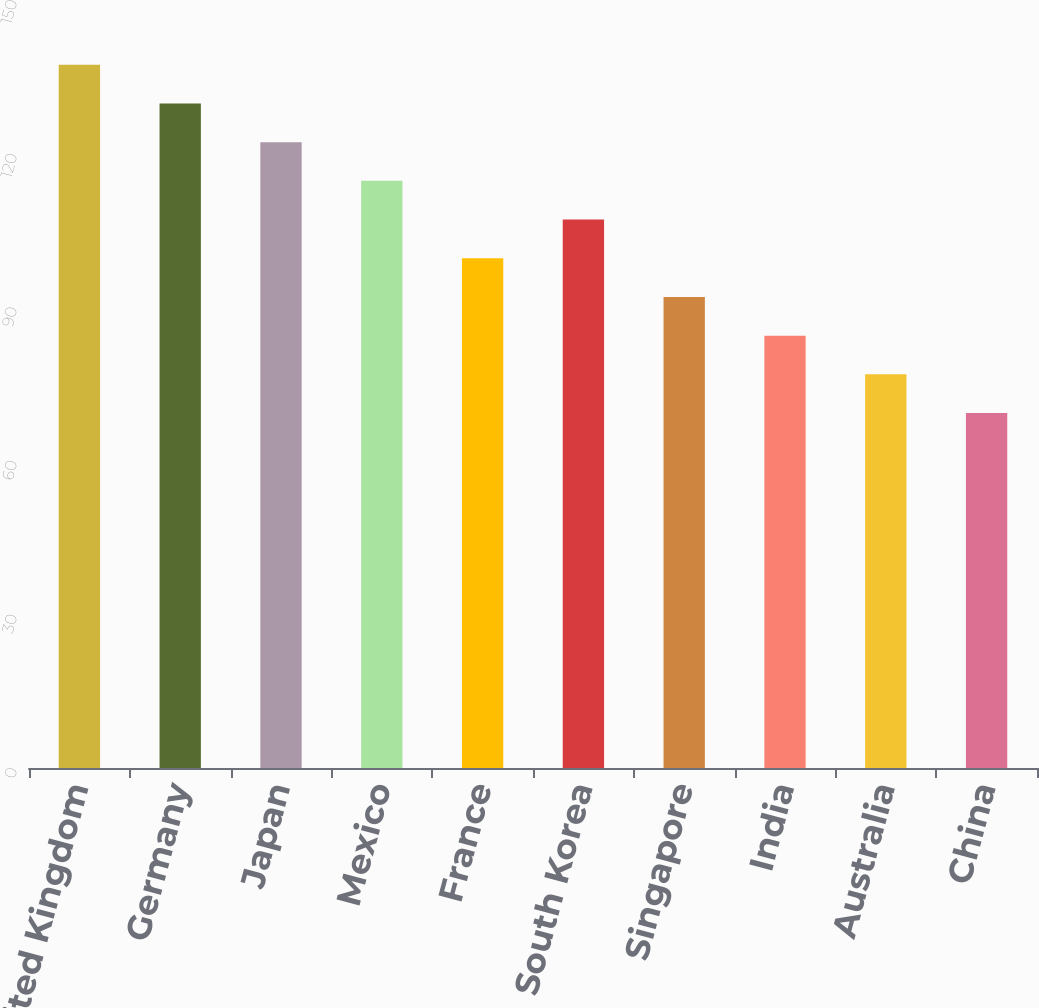Convert chart to OTSL. <chart><loc_0><loc_0><loc_500><loc_500><bar_chart><fcel>United Kingdom<fcel>Germany<fcel>Japan<fcel>Mexico<fcel>France<fcel>South Korea<fcel>Singapore<fcel>India<fcel>Australia<fcel>China<nl><fcel>137.36<fcel>129.8<fcel>122.24<fcel>114.68<fcel>99.56<fcel>107.12<fcel>92<fcel>84.44<fcel>76.88<fcel>69.32<nl></chart> 